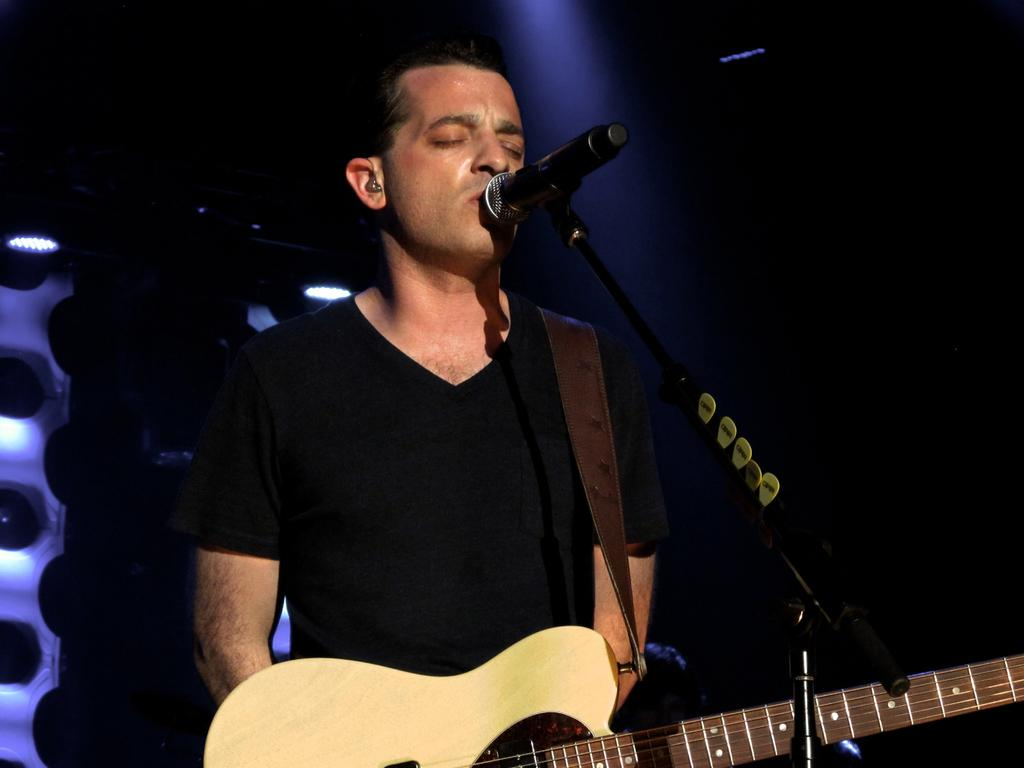What is the person in the image doing? The person is standing, holding a guitar, singing a song, and using a microphone. What object is the person holding in the image? The person is holding a guitar in the image. How is the person's voice being amplified in the image? The person is using a microphone to amplify their voice. What type of plastic is visible in the image? There is no plastic visible in the image. Can you see a window in the background of the image? There is no window visible in the image. 